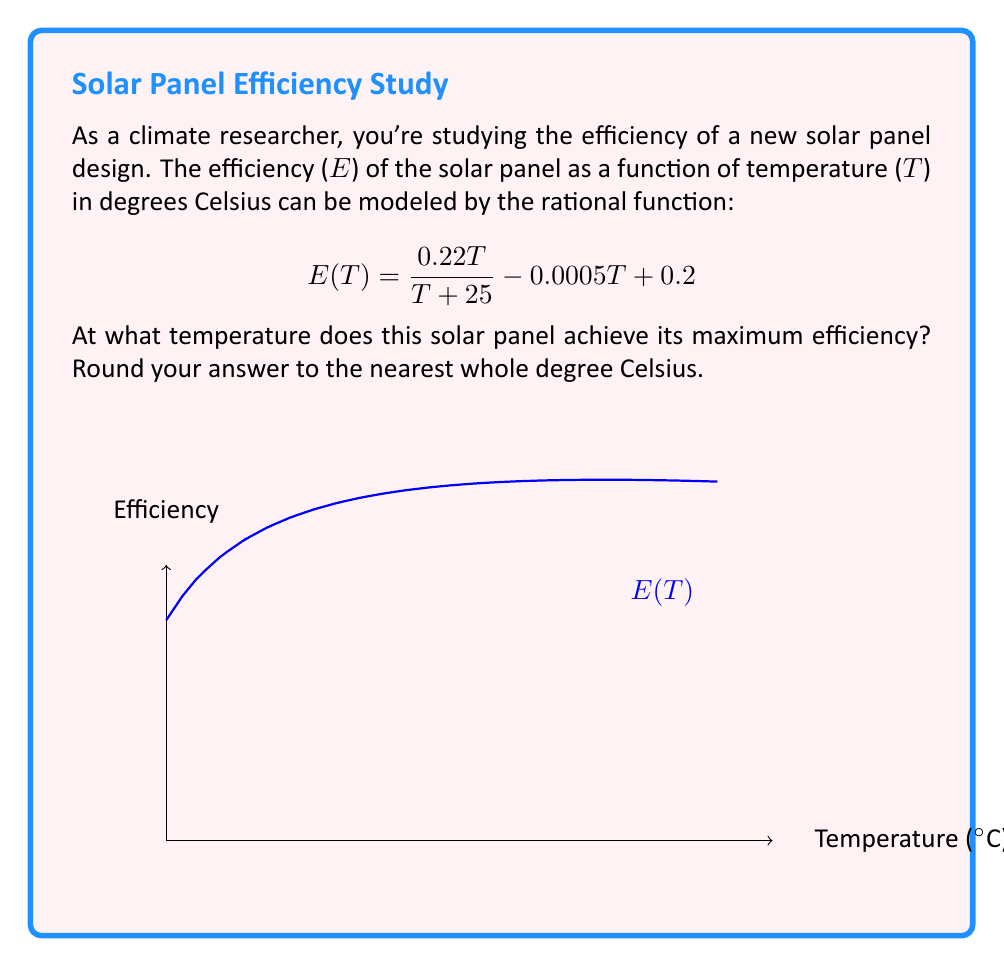Could you help me with this problem? To find the maximum efficiency, we need to follow these steps:

1) First, we need to find the derivative of E(T) and set it equal to zero:

   $$E'(T) = \frac{0.22(T+25) - 0.22T}{(T+25)^2} - 0.0005 = 0$$

2) Simplify the numerator:

   $$\frac{0.22(25)}{(T+25)^2} - 0.0005 = 0$$

3) Multiply both sides by $(T+25)^2$:

   $$5.5 - 0.0005(T+25)^2 = 0$$

4) Expand the squared term:

   $$5.5 - 0.0005(T^2 + 50T + 625) = 0$$

5) Distribute the negative:

   $$5.5 - 0.0005T^2 - 0.025T - 0.3125 = 0$$

6) Rearrange to standard quadratic form:

   $$0.0005T^2 + 0.025T - 5.1875 = 0$$

7) Use the quadratic formula to solve for T:

   $$T = \frac{-0.025 \pm \sqrt{0.025^2 + 4(0.0005)(5.1875)}}{2(0.0005)}$$

8) Simplify and calculate:

   $$T \approx 48.78 \text{ or } -213.78$$

9) Since temperature can't be negative in this context, we take the positive solution.

10) Rounding to the nearest whole number:

    T ≈ 49°C
Answer: 49°C 